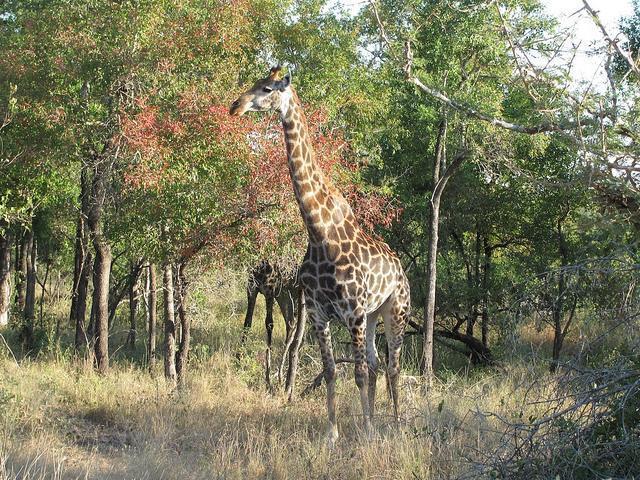How many giraffes are in the picture?
Give a very brief answer. 2. How many giraffe are in the forest?
Give a very brief answer. 2. How many giraffes can be seen?
Give a very brief answer. 2. 